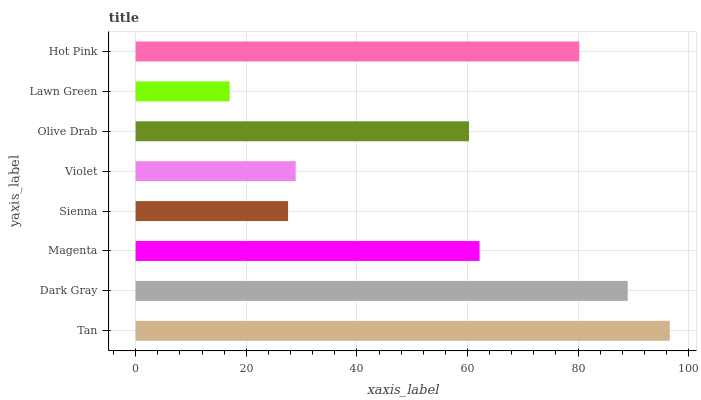Is Lawn Green the minimum?
Answer yes or no. Yes. Is Tan the maximum?
Answer yes or no. Yes. Is Dark Gray the minimum?
Answer yes or no. No. Is Dark Gray the maximum?
Answer yes or no. No. Is Tan greater than Dark Gray?
Answer yes or no. Yes. Is Dark Gray less than Tan?
Answer yes or no. Yes. Is Dark Gray greater than Tan?
Answer yes or no. No. Is Tan less than Dark Gray?
Answer yes or no. No. Is Magenta the high median?
Answer yes or no. Yes. Is Olive Drab the low median?
Answer yes or no. Yes. Is Hot Pink the high median?
Answer yes or no. No. Is Lawn Green the low median?
Answer yes or no. No. 